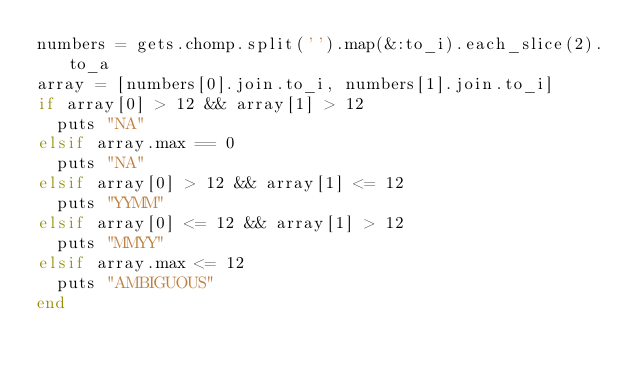<code> <loc_0><loc_0><loc_500><loc_500><_Ruby_>numbers = gets.chomp.split('').map(&:to_i).each_slice(2).to_a
array = [numbers[0].join.to_i, numbers[1].join.to_i]
if array[0] > 12 && array[1] > 12
  puts "NA"
elsif array.max == 0
  puts "NA"
elsif array[0] > 12 && array[1] <= 12
  puts "YYMM"
elsif array[0] <= 12 && array[1] > 12
  puts "MMYY"
elsif array.max <= 12
  puts "AMBIGUOUS"
end</code> 